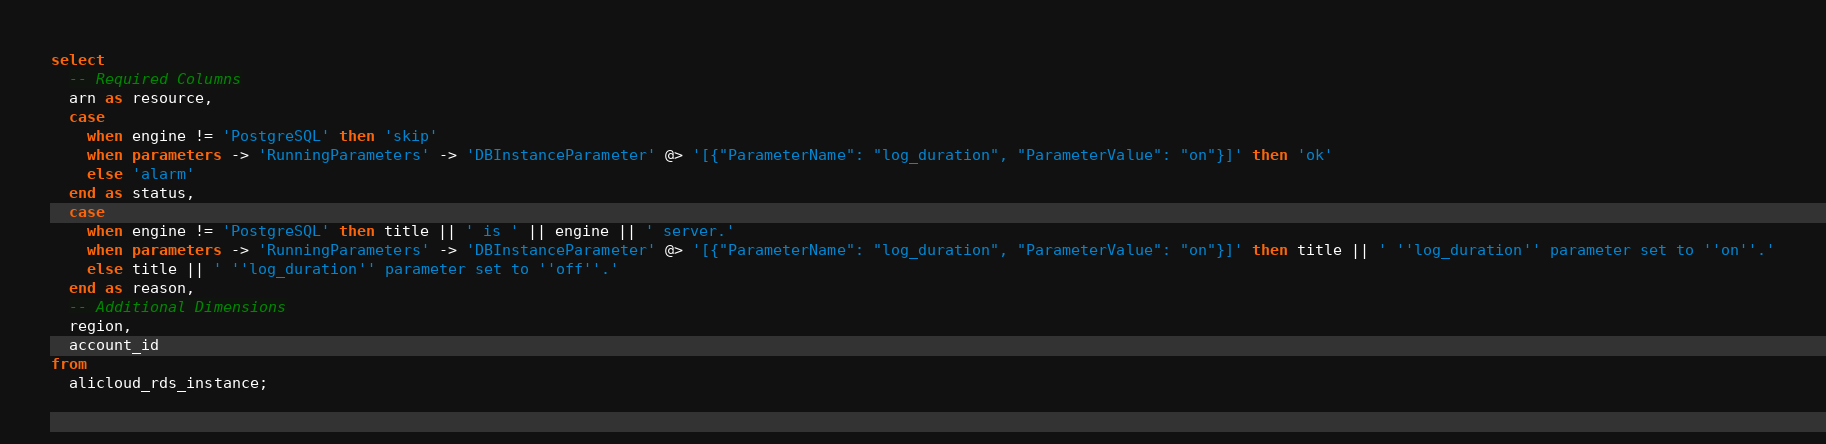Convert code to text. <code><loc_0><loc_0><loc_500><loc_500><_SQL_>select
  -- Required Columns
  arn as resource,
  case
    when engine != 'PostgreSQL' then 'skip'
    when parameters -> 'RunningParameters' -> 'DBInstanceParameter' @> '[{"ParameterName": "log_duration", "ParameterValue": "on"}]' then 'ok'
    else 'alarm'
  end as status,
  case
    when engine != 'PostgreSQL' then title || ' is ' || engine || ' server.'
    when parameters -> 'RunningParameters' -> 'DBInstanceParameter' @> '[{"ParameterName": "log_duration", "ParameterValue": "on"}]' then title || ' ''log_duration'' parameter set to ''on''.'
    else title || ' ''log_duration'' parameter set to ''off''.'
  end as reason,
  -- Additional Dimensions
  region,
  account_id
from
  alicloud_rds_instance;</code> 